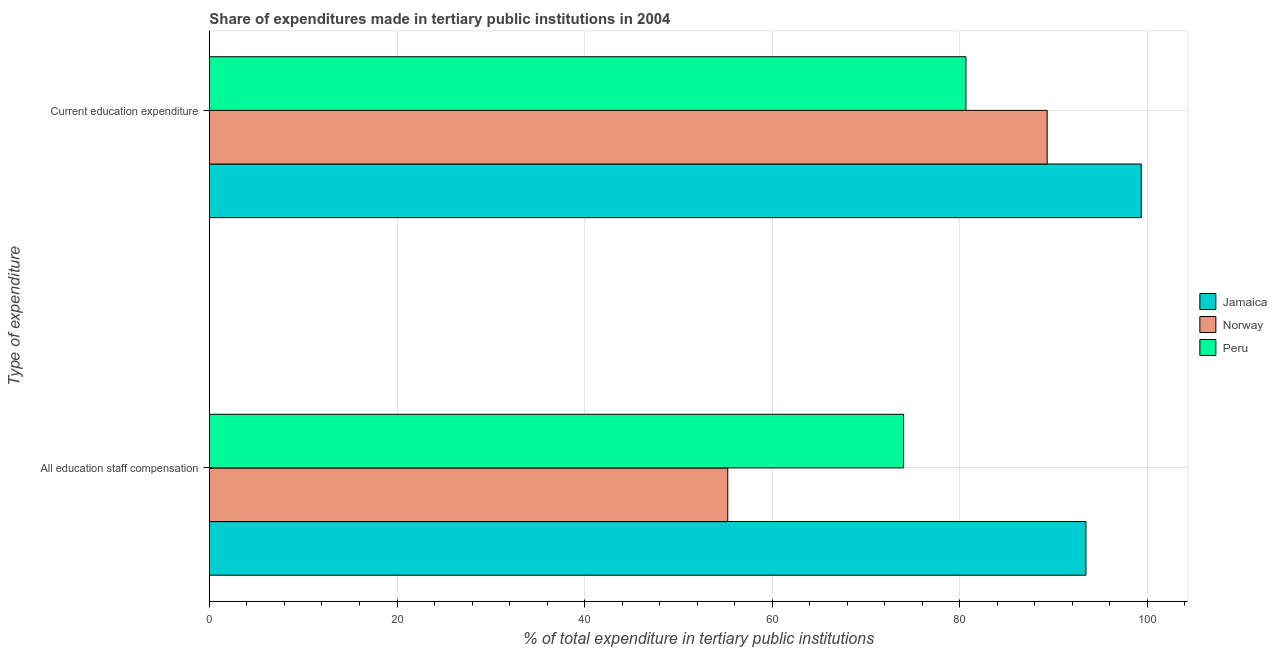How many groups of bars are there?
Offer a terse response. 2. Are the number of bars per tick equal to the number of legend labels?
Ensure brevity in your answer.  Yes. Are the number of bars on each tick of the Y-axis equal?
Give a very brief answer. Yes. How many bars are there on the 2nd tick from the bottom?
Your response must be concise. 3. What is the label of the 1st group of bars from the top?
Give a very brief answer. Current education expenditure. What is the expenditure in staff compensation in Norway?
Your response must be concise. 55.27. Across all countries, what is the maximum expenditure in staff compensation?
Your answer should be very brief. 93.46. Across all countries, what is the minimum expenditure in staff compensation?
Provide a short and direct response. 55.27. In which country was the expenditure in staff compensation maximum?
Keep it short and to the point. Jamaica. What is the total expenditure in education in the graph?
Give a very brief answer. 269.34. What is the difference between the expenditure in staff compensation in Norway and that in Jamaica?
Your response must be concise. -38.19. What is the difference between the expenditure in staff compensation in Norway and the expenditure in education in Jamaica?
Your answer should be compact. -44.09. What is the average expenditure in education per country?
Your answer should be compact. 89.78. What is the difference between the expenditure in education and expenditure in staff compensation in Peru?
Your answer should be very brief. 6.65. In how many countries, is the expenditure in staff compensation greater than 32 %?
Keep it short and to the point. 3. What is the ratio of the expenditure in staff compensation in Peru to that in Norway?
Keep it short and to the point. 1.34. In how many countries, is the expenditure in staff compensation greater than the average expenditure in staff compensation taken over all countries?
Make the answer very short. 1. What does the 2nd bar from the top in Current education expenditure represents?
Offer a terse response. Norway. What does the 3rd bar from the bottom in Current education expenditure represents?
Ensure brevity in your answer.  Peru. Are all the bars in the graph horizontal?
Your response must be concise. Yes. How many countries are there in the graph?
Provide a short and direct response. 3. What is the difference between two consecutive major ticks on the X-axis?
Provide a succinct answer. 20. Where does the legend appear in the graph?
Give a very brief answer. Center right. How many legend labels are there?
Ensure brevity in your answer.  3. What is the title of the graph?
Provide a short and direct response. Share of expenditures made in tertiary public institutions in 2004. What is the label or title of the X-axis?
Your answer should be compact. % of total expenditure in tertiary public institutions. What is the label or title of the Y-axis?
Ensure brevity in your answer.  Type of expenditure. What is the % of total expenditure in tertiary public institutions of Jamaica in All education staff compensation?
Make the answer very short. 93.46. What is the % of total expenditure in tertiary public institutions of Norway in All education staff compensation?
Give a very brief answer. 55.27. What is the % of total expenditure in tertiary public institutions of Peru in All education staff compensation?
Ensure brevity in your answer.  74.02. What is the % of total expenditure in tertiary public institutions in Jamaica in Current education expenditure?
Give a very brief answer. 99.35. What is the % of total expenditure in tertiary public institutions in Norway in Current education expenditure?
Your response must be concise. 89.32. What is the % of total expenditure in tertiary public institutions in Peru in Current education expenditure?
Provide a succinct answer. 80.66. Across all Type of expenditure, what is the maximum % of total expenditure in tertiary public institutions of Jamaica?
Provide a short and direct response. 99.35. Across all Type of expenditure, what is the maximum % of total expenditure in tertiary public institutions of Norway?
Ensure brevity in your answer.  89.32. Across all Type of expenditure, what is the maximum % of total expenditure in tertiary public institutions of Peru?
Ensure brevity in your answer.  80.66. Across all Type of expenditure, what is the minimum % of total expenditure in tertiary public institutions in Jamaica?
Ensure brevity in your answer.  93.46. Across all Type of expenditure, what is the minimum % of total expenditure in tertiary public institutions of Norway?
Provide a succinct answer. 55.27. Across all Type of expenditure, what is the minimum % of total expenditure in tertiary public institutions of Peru?
Your response must be concise. 74.02. What is the total % of total expenditure in tertiary public institutions of Jamaica in the graph?
Make the answer very short. 192.81. What is the total % of total expenditure in tertiary public institutions of Norway in the graph?
Your answer should be very brief. 144.59. What is the total % of total expenditure in tertiary public institutions in Peru in the graph?
Your answer should be very brief. 154.68. What is the difference between the % of total expenditure in tertiary public institutions of Jamaica in All education staff compensation and that in Current education expenditure?
Your answer should be compact. -5.9. What is the difference between the % of total expenditure in tertiary public institutions of Norway in All education staff compensation and that in Current education expenditure?
Ensure brevity in your answer.  -34.05. What is the difference between the % of total expenditure in tertiary public institutions of Peru in All education staff compensation and that in Current education expenditure?
Make the answer very short. -6.65. What is the difference between the % of total expenditure in tertiary public institutions in Jamaica in All education staff compensation and the % of total expenditure in tertiary public institutions in Norway in Current education expenditure?
Your answer should be very brief. 4.13. What is the difference between the % of total expenditure in tertiary public institutions of Jamaica in All education staff compensation and the % of total expenditure in tertiary public institutions of Peru in Current education expenditure?
Keep it short and to the point. 12.79. What is the difference between the % of total expenditure in tertiary public institutions in Norway in All education staff compensation and the % of total expenditure in tertiary public institutions in Peru in Current education expenditure?
Make the answer very short. -25.39. What is the average % of total expenditure in tertiary public institutions in Jamaica per Type of expenditure?
Make the answer very short. 96.4. What is the average % of total expenditure in tertiary public institutions of Norway per Type of expenditure?
Provide a succinct answer. 72.3. What is the average % of total expenditure in tertiary public institutions in Peru per Type of expenditure?
Provide a short and direct response. 77.34. What is the difference between the % of total expenditure in tertiary public institutions in Jamaica and % of total expenditure in tertiary public institutions in Norway in All education staff compensation?
Give a very brief answer. 38.19. What is the difference between the % of total expenditure in tertiary public institutions of Jamaica and % of total expenditure in tertiary public institutions of Peru in All education staff compensation?
Provide a short and direct response. 19.44. What is the difference between the % of total expenditure in tertiary public institutions of Norway and % of total expenditure in tertiary public institutions of Peru in All education staff compensation?
Your answer should be very brief. -18.75. What is the difference between the % of total expenditure in tertiary public institutions of Jamaica and % of total expenditure in tertiary public institutions of Norway in Current education expenditure?
Provide a succinct answer. 10.03. What is the difference between the % of total expenditure in tertiary public institutions of Jamaica and % of total expenditure in tertiary public institutions of Peru in Current education expenditure?
Offer a terse response. 18.69. What is the difference between the % of total expenditure in tertiary public institutions of Norway and % of total expenditure in tertiary public institutions of Peru in Current education expenditure?
Offer a terse response. 8.66. What is the ratio of the % of total expenditure in tertiary public institutions in Jamaica in All education staff compensation to that in Current education expenditure?
Ensure brevity in your answer.  0.94. What is the ratio of the % of total expenditure in tertiary public institutions of Norway in All education staff compensation to that in Current education expenditure?
Your response must be concise. 0.62. What is the ratio of the % of total expenditure in tertiary public institutions in Peru in All education staff compensation to that in Current education expenditure?
Provide a succinct answer. 0.92. What is the difference between the highest and the second highest % of total expenditure in tertiary public institutions of Jamaica?
Your answer should be very brief. 5.9. What is the difference between the highest and the second highest % of total expenditure in tertiary public institutions of Norway?
Offer a terse response. 34.05. What is the difference between the highest and the second highest % of total expenditure in tertiary public institutions in Peru?
Keep it short and to the point. 6.65. What is the difference between the highest and the lowest % of total expenditure in tertiary public institutions of Jamaica?
Your answer should be compact. 5.9. What is the difference between the highest and the lowest % of total expenditure in tertiary public institutions in Norway?
Offer a very short reply. 34.05. What is the difference between the highest and the lowest % of total expenditure in tertiary public institutions of Peru?
Provide a short and direct response. 6.65. 